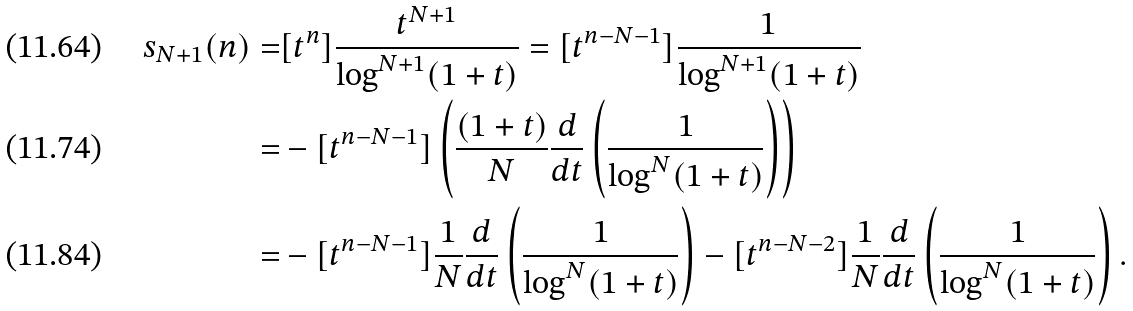Convert formula to latex. <formula><loc_0><loc_0><loc_500><loc_500>s _ { N + 1 } ( n ) = & [ t ^ { n } ] \frac { t ^ { N + 1 } } { \log ^ { N + 1 } ( 1 + t ) } = [ t ^ { n - N - 1 } ] \frac { 1 } { \log ^ { N + 1 } ( 1 + t ) } \\ = & - [ t ^ { n - N - 1 } ] \left ( \frac { ( 1 + t ) } { N } \frac { d } { d t } \left ( \frac { 1 } { \log ^ { N } ( 1 + t ) } \right ) \right ) \\ = & - [ t ^ { n - N - 1 } ] \frac { 1 } { N } \frac { d } { d t } \left ( \frac { 1 } { \log ^ { N } ( 1 + t ) } \right ) - [ t ^ { n - N - 2 } ] \frac { 1 } { N } \frac { d } { d t } \left ( \frac { 1 } { \log ^ { N } ( 1 + t ) } \right ) .</formula> 